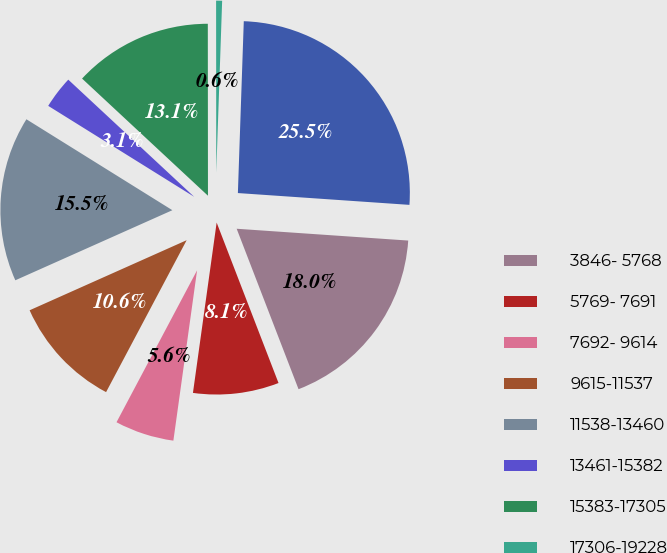Convert chart to OTSL. <chart><loc_0><loc_0><loc_500><loc_500><pie_chart><fcel>3846- 5768<fcel>5769- 7691<fcel>7692- 9614<fcel>9615-11537<fcel>11538-13460<fcel>13461-15382<fcel>15383-17305<fcel>17306-19228<fcel>3846-19228<nl><fcel>18.05%<fcel>8.06%<fcel>5.56%<fcel>10.56%<fcel>15.55%<fcel>3.06%<fcel>13.06%<fcel>0.56%<fcel>25.55%<nl></chart> 